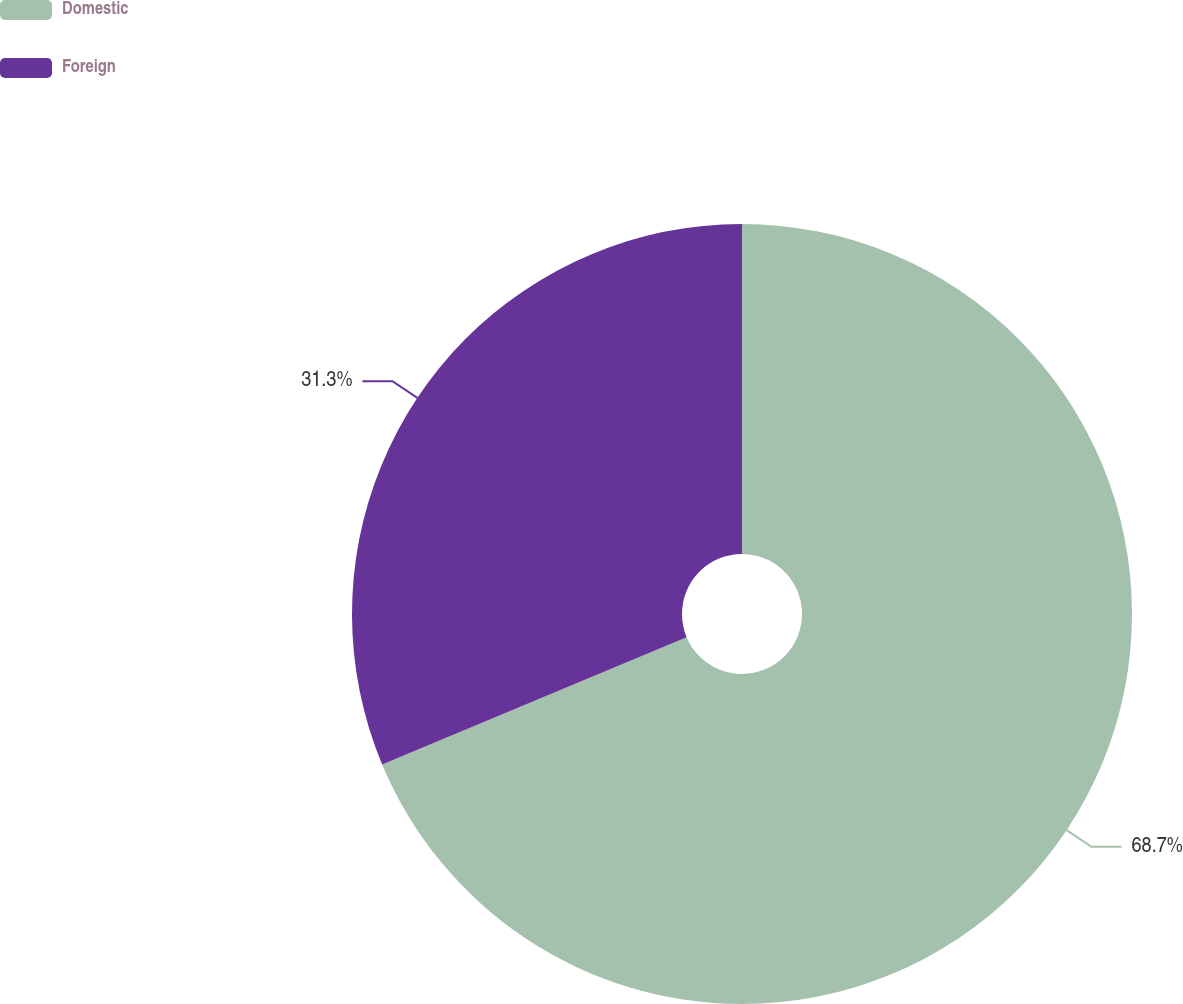Convert chart. <chart><loc_0><loc_0><loc_500><loc_500><pie_chart><fcel>Domestic<fcel>Foreign<nl><fcel>68.7%<fcel>31.3%<nl></chart> 